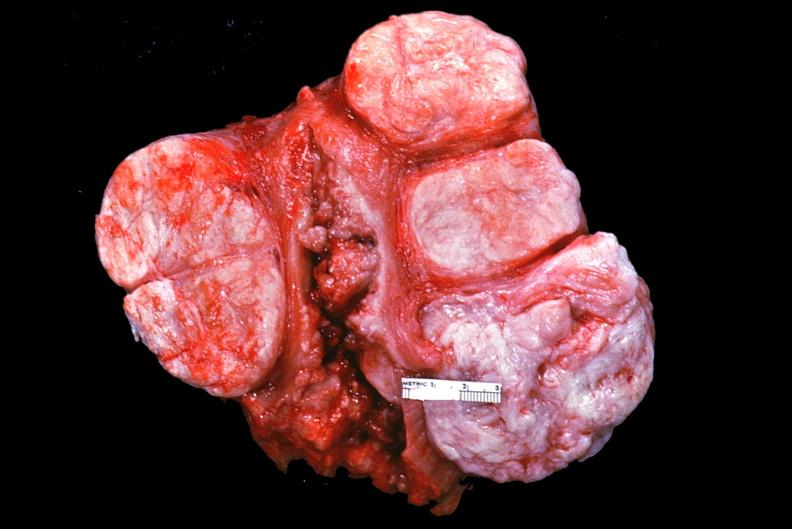where does this part belong to?
Answer the question using a single word or phrase. Female reproductive system 